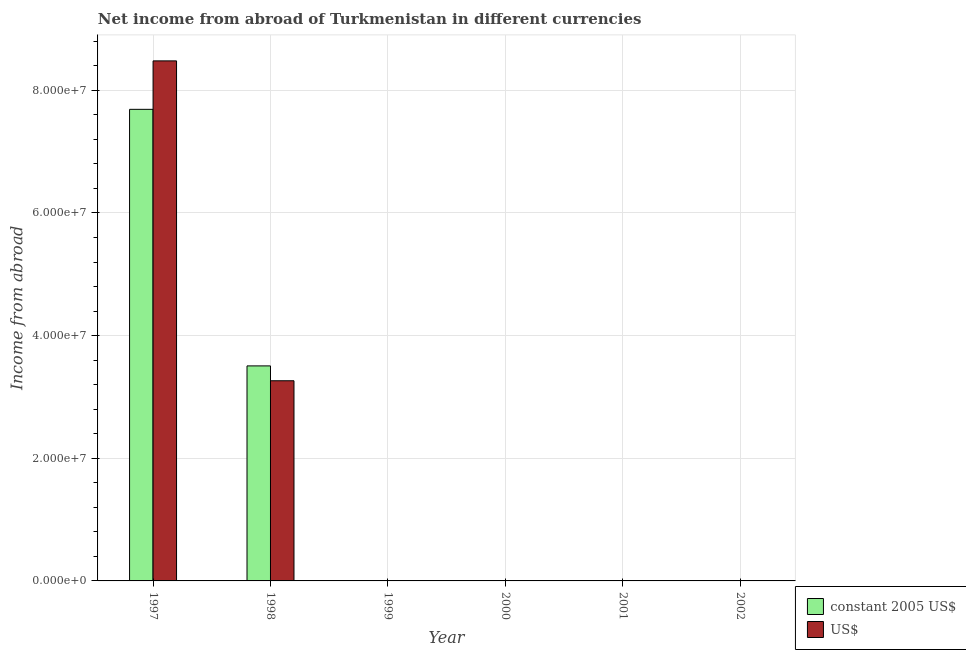How many different coloured bars are there?
Give a very brief answer. 2. Are the number of bars per tick equal to the number of legend labels?
Give a very brief answer. No. How many bars are there on the 3rd tick from the left?
Offer a very short reply. 0. How many bars are there on the 1st tick from the right?
Give a very brief answer. 0. In how many cases, is the number of bars for a given year not equal to the number of legend labels?
Offer a very short reply. 4. What is the income from abroad in us$ in 2002?
Provide a short and direct response. 0. Across all years, what is the maximum income from abroad in constant 2005 us$?
Your response must be concise. 7.69e+07. Across all years, what is the minimum income from abroad in constant 2005 us$?
Your response must be concise. 0. In which year was the income from abroad in constant 2005 us$ maximum?
Provide a succinct answer. 1997. What is the total income from abroad in constant 2005 us$ in the graph?
Keep it short and to the point. 1.12e+08. What is the average income from abroad in constant 2005 us$ per year?
Your answer should be very brief. 1.87e+07. In the year 1997, what is the difference between the income from abroad in us$ and income from abroad in constant 2005 us$?
Ensure brevity in your answer.  0. In how many years, is the income from abroad in constant 2005 us$ greater than 84000000 units?
Make the answer very short. 0. What is the difference between the highest and the lowest income from abroad in constant 2005 us$?
Offer a very short reply. 7.69e+07. Is the sum of the income from abroad in constant 2005 us$ in 1997 and 1998 greater than the maximum income from abroad in us$ across all years?
Offer a very short reply. Yes. How many bars are there?
Your answer should be compact. 4. Are all the bars in the graph horizontal?
Offer a terse response. No. How many years are there in the graph?
Your response must be concise. 6. What is the difference between two consecutive major ticks on the Y-axis?
Provide a short and direct response. 2.00e+07. Are the values on the major ticks of Y-axis written in scientific E-notation?
Offer a very short reply. Yes. Does the graph contain grids?
Keep it short and to the point. Yes. Where does the legend appear in the graph?
Offer a very short reply. Bottom right. How are the legend labels stacked?
Make the answer very short. Vertical. What is the title of the graph?
Offer a very short reply. Net income from abroad of Turkmenistan in different currencies. What is the label or title of the X-axis?
Provide a succinct answer. Year. What is the label or title of the Y-axis?
Provide a short and direct response. Income from abroad. What is the Income from abroad in constant 2005 US$ in 1997?
Offer a terse response. 7.69e+07. What is the Income from abroad in US$ in 1997?
Provide a succinct answer. 8.48e+07. What is the Income from abroad of constant 2005 US$ in 1998?
Offer a terse response. 3.51e+07. What is the Income from abroad of US$ in 1998?
Offer a terse response. 3.26e+07. What is the Income from abroad of US$ in 1999?
Your answer should be compact. 0. What is the Income from abroad in US$ in 2000?
Provide a succinct answer. 0. What is the Income from abroad in constant 2005 US$ in 2001?
Provide a succinct answer. 0. What is the Income from abroad in US$ in 2002?
Give a very brief answer. 0. Across all years, what is the maximum Income from abroad of constant 2005 US$?
Provide a succinct answer. 7.69e+07. Across all years, what is the maximum Income from abroad of US$?
Provide a succinct answer. 8.48e+07. What is the total Income from abroad of constant 2005 US$ in the graph?
Make the answer very short. 1.12e+08. What is the total Income from abroad in US$ in the graph?
Provide a short and direct response. 1.17e+08. What is the difference between the Income from abroad of constant 2005 US$ in 1997 and that in 1998?
Your answer should be very brief. 4.18e+07. What is the difference between the Income from abroad of US$ in 1997 and that in 1998?
Your answer should be compact. 5.22e+07. What is the difference between the Income from abroad in constant 2005 US$ in 1997 and the Income from abroad in US$ in 1998?
Provide a succinct answer. 4.43e+07. What is the average Income from abroad of constant 2005 US$ per year?
Your answer should be very brief. 1.87e+07. What is the average Income from abroad of US$ per year?
Provide a succinct answer. 1.96e+07. In the year 1997, what is the difference between the Income from abroad of constant 2005 US$ and Income from abroad of US$?
Provide a succinct answer. -7.90e+06. In the year 1998, what is the difference between the Income from abroad of constant 2005 US$ and Income from abroad of US$?
Your answer should be very brief. 2.42e+06. What is the ratio of the Income from abroad in constant 2005 US$ in 1997 to that in 1998?
Your response must be concise. 2.19. What is the ratio of the Income from abroad in US$ in 1997 to that in 1998?
Ensure brevity in your answer.  2.6. What is the difference between the highest and the lowest Income from abroad of constant 2005 US$?
Your answer should be very brief. 7.69e+07. What is the difference between the highest and the lowest Income from abroad of US$?
Keep it short and to the point. 8.48e+07. 